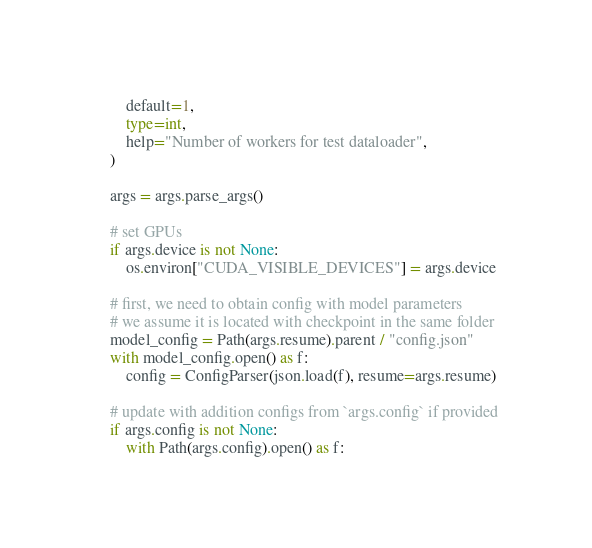Convert code to text. <code><loc_0><loc_0><loc_500><loc_500><_Python_>        default=1,
        type=int,
        help="Number of workers for test dataloader",
    )

    args = args.parse_args()

    # set GPUs
    if args.device is not None:
        os.environ["CUDA_VISIBLE_DEVICES"] = args.device

    # first, we need to obtain config with model parameters
    # we assume it is located with checkpoint in the same folder
    model_config = Path(args.resume).parent / "config.json"
    with model_config.open() as f:
        config = ConfigParser(json.load(f), resume=args.resume)

    # update with addition configs from `args.config` if provided
    if args.config is not None:
        with Path(args.config).open() as f:</code> 